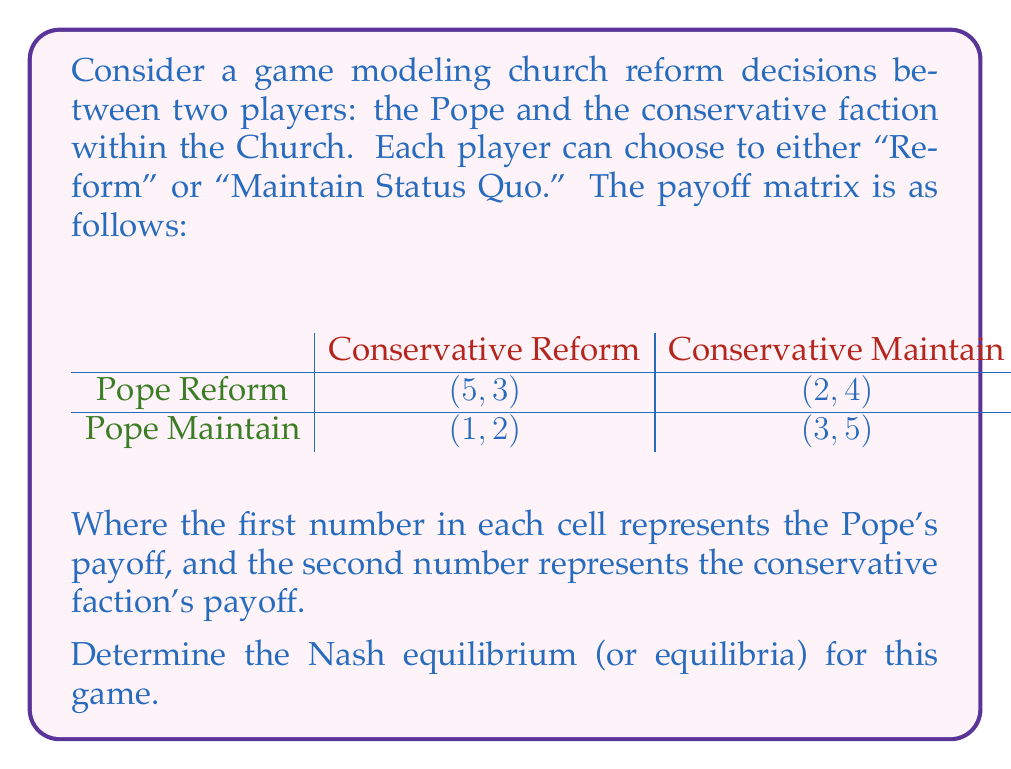Can you solve this math problem? To find the Nash equilibrium, we need to determine the best response for each player given the other player's strategy.

1. Pope's perspective:
   - If Conservative faction chooses Reform:
     Pope's payoff for Reform: 5
     Pope's payoff for Maintain: 1
     Best response: Reform
   - If Conservative faction chooses Maintain:
     Pope's payoff for Reform: 2
     Pope's payoff for Maintain: 3
     Best response: Maintain

2. Conservative faction's perspective:
   - If Pope chooses Reform:
     Conservative's payoff for Reform: 3
     Conservative's payoff for Maintain: 4
     Best response: Maintain
   - If Pope chooses Maintain:
     Conservative's payoff for Reform: 2
     Conservative's payoff for Maintain: 5
     Best response: Maintain

3. Identifying Nash equilibria:
   - (Pope Reform, Conservative Reform) is not an equilibrium because Conservative would deviate to Maintain.
   - (Pope Reform, Conservative Maintain) is not an equilibrium because Pope would deviate to Maintain.
   - (Pope Maintain, Conservative Reform) is not an equilibrium because Conservative would deviate to Maintain.
   - (Pope Maintain, Conservative Maintain) is an equilibrium because neither player has an incentive to deviate.

Therefore, there is one pure strategy Nash equilibrium in this game.
Answer: The Nash equilibrium for this game is (Pope Maintain, Conservative Maintain) with payoffs (3, 5). 